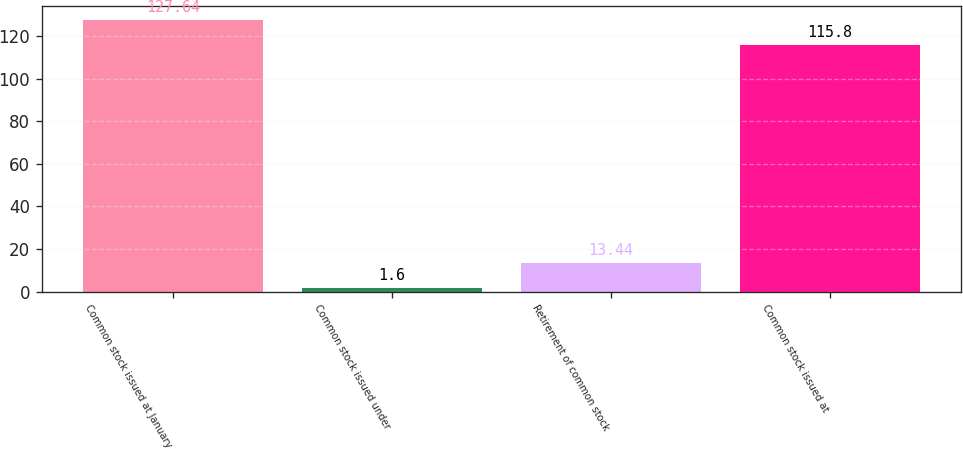Convert chart to OTSL. <chart><loc_0><loc_0><loc_500><loc_500><bar_chart><fcel>Common stock issued at January<fcel>Common stock issued under<fcel>Retirement of common stock<fcel>Common stock issued at<nl><fcel>127.64<fcel>1.6<fcel>13.44<fcel>115.8<nl></chart> 